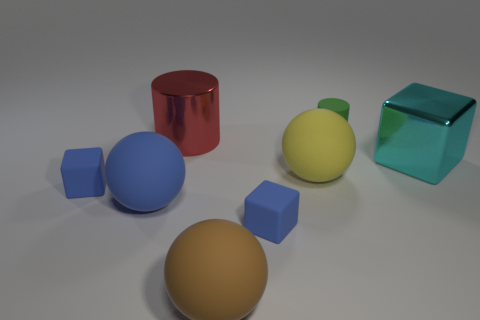Add 1 shiny spheres. How many objects exist? 9 Subtract all cylinders. How many objects are left? 6 Subtract all large purple rubber balls. Subtract all green things. How many objects are left? 7 Add 7 large brown things. How many large brown things are left? 8 Add 8 blue cylinders. How many blue cylinders exist? 8 Subtract 0 green cubes. How many objects are left? 8 